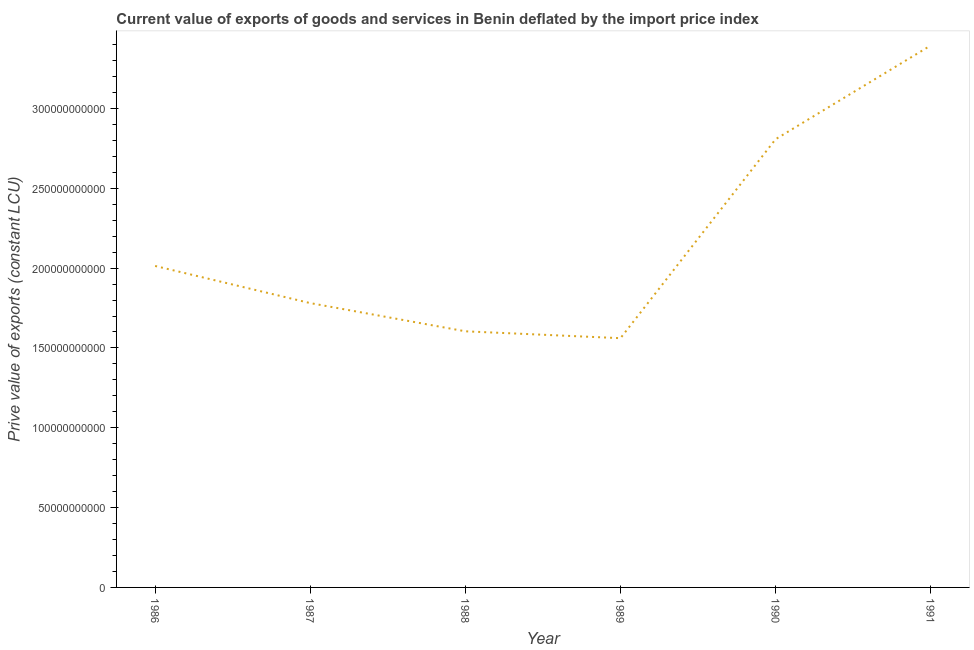What is the price value of exports in 1990?
Offer a very short reply. 2.81e+11. Across all years, what is the maximum price value of exports?
Your answer should be compact. 3.39e+11. Across all years, what is the minimum price value of exports?
Ensure brevity in your answer.  1.56e+11. In which year was the price value of exports maximum?
Offer a terse response. 1991. In which year was the price value of exports minimum?
Provide a succinct answer. 1989. What is the sum of the price value of exports?
Keep it short and to the point. 1.32e+12. What is the difference between the price value of exports in 1986 and 1988?
Offer a terse response. 4.09e+1. What is the average price value of exports per year?
Offer a terse response. 2.19e+11. What is the median price value of exports?
Offer a terse response. 1.90e+11. What is the ratio of the price value of exports in 1987 to that in 1990?
Offer a very short reply. 0.63. Is the price value of exports in 1989 less than that in 1991?
Your answer should be compact. Yes. Is the difference between the price value of exports in 1987 and 1988 greater than the difference between any two years?
Keep it short and to the point. No. What is the difference between the highest and the second highest price value of exports?
Your answer should be compact. 5.87e+1. Is the sum of the price value of exports in 1987 and 1991 greater than the maximum price value of exports across all years?
Offer a terse response. Yes. What is the difference between the highest and the lowest price value of exports?
Your answer should be compact. 1.83e+11. How many years are there in the graph?
Offer a very short reply. 6. What is the difference between two consecutive major ticks on the Y-axis?
Your response must be concise. 5.00e+1. What is the title of the graph?
Provide a succinct answer. Current value of exports of goods and services in Benin deflated by the import price index. What is the label or title of the X-axis?
Your response must be concise. Year. What is the label or title of the Y-axis?
Make the answer very short. Prive value of exports (constant LCU). What is the Prive value of exports (constant LCU) in 1986?
Provide a succinct answer. 2.01e+11. What is the Prive value of exports (constant LCU) in 1987?
Ensure brevity in your answer.  1.78e+11. What is the Prive value of exports (constant LCU) in 1988?
Offer a very short reply. 1.60e+11. What is the Prive value of exports (constant LCU) in 1989?
Keep it short and to the point. 1.56e+11. What is the Prive value of exports (constant LCU) in 1990?
Ensure brevity in your answer.  2.81e+11. What is the Prive value of exports (constant LCU) of 1991?
Your answer should be very brief. 3.39e+11. What is the difference between the Prive value of exports (constant LCU) in 1986 and 1987?
Your answer should be very brief. 2.33e+1. What is the difference between the Prive value of exports (constant LCU) in 1986 and 1988?
Make the answer very short. 4.09e+1. What is the difference between the Prive value of exports (constant LCU) in 1986 and 1989?
Offer a very short reply. 4.52e+1. What is the difference between the Prive value of exports (constant LCU) in 1986 and 1990?
Ensure brevity in your answer.  -7.94e+1. What is the difference between the Prive value of exports (constant LCU) in 1986 and 1991?
Ensure brevity in your answer.  -1.38e+11. What is the difference between the Prive value of exports (constant LCU) in 1987 and 1988?
Your answer should be compact. 1.77e+1. What is the difference between the Prive value of exports (constant LCU) in 1987 and 1989?
Your answer should be very brief. 2.20e+1. What is the difference between the Prive value of exports (constant LCU) in 1987 and 1990?
Your answer should be very brief. -1.03e+11. What is the difference between the Prive value of exports (constant LCU) in 1987 and 1991?
Your answer should be very brief. -1.61e+11. What is the difference between the Prive value of exports (constant LCU) in 1988 and 1989?
Ensure brevity in your answer.  4.31e+09. What is the difference between the Prive value of exports (constant LCU) in 1988 and 1990?
Keep it short and to the point. -1.20e+11. What is the difference between the Prive value of exports (constant LCU) in 1988 and 1991?
Your answer should be very brief. -1.79e+11. What is the difference between the Prive value of exports (constant LCU) in 1989 and 1990?
Your answer should be very brief. -1.25e+11. What is the difference between the Prive value of exports (constant LCU) in 1989 and 1991?
Make the answer very short. -1.83e+11. What is the difference between the Prive value of exports (constant LCU) in 1990 and 1991?
Your response must be concise. -5.87e+1. What is the ratio of the Prive value of exports (constant LCU) in 1986 to that in 1987?
Give a very brief answer. 1.13. What is the ratio of the Prive value of exports (constant LCU) in 1986 to that in 1988?
Keep it short and to the point. 1.25. What is the ratio of the Prive value of exports (constant LCU) in 1986 to that in 1989?
Offer a terse response. 1.29. What is the ratio of the Prive value of exports (constant LCU) in 1986 to that in 1990?
Provide a succinct answer. 0.72. What is the ratio of the Prive value of exports (constant LCU) in 1986 to that in 1991?
Offer a terse response. 0.59. What is the ratio of the Prive value of exports (constant LCU) in 1987 to that in 1988?
Give a very brief answer. 1.11. What is the ratio of the Prive value of exports (constant LCU) in 1987 to that in 1989?
Your answer should be compact. 1.14. What is the ratio of the Prive value of exports (constant LCU) in 1987 to that in 1990?
Make the answer very short. 0.63. What is the ratio of the Prive value of exports (constant LCU) in 1987 to that in 1991?
Provide a short and direct response. 0.53. What is the ratio of the Prive value of exports (constant LCU) in 1988 to that in 1989?
Offer a very short reply. 1.03. What is the ratio of the Prive value of exports (constant LCU) in 1988 to that in 1990?
Offer a very short reply. 0.57. What is the ratio of the Prive value of exports (constant LCU) in 1988 to that in 1991?
Your answer should be compact. 0.47. What is the ratio of the Prive value of exports (constant LCU) in 1989 to that in 1990?
Offer a very short reply. 0.56. What is the ratio of the Prive value of exports (constant LCU) in 1989 to that in 1991?
Your answer should be very brief. 0.46. What is the ratio of the Prive value of exports (constant LCU) in 1990 to that in 1991?
Your response must be concise. 0.83. 